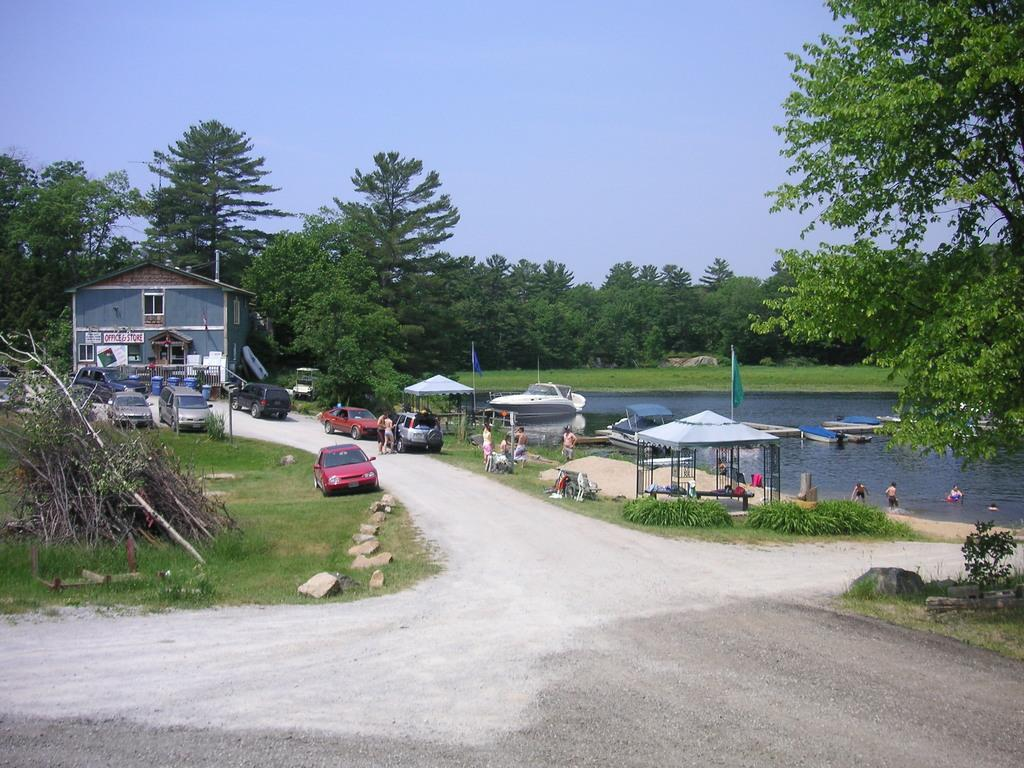What type of structure can be seen in the image? There is a building in the image. What is in the water near the building? There are boats in the water. What can be seen on the road and in the water? There are people on the road and in the water. What types of vehicles are on the road? There are vehicles on the road. What type of vegetation is present in the image? Grass and trees are visible in the image. What other objects can be seen in the image? Sticks and stones are present in the image. What part of the natural environment is visible in the image? The sky is visible in the image. Can you tell me how many houses are being combed by worms in the image? There are no houses, combs, or worms present in the image. 